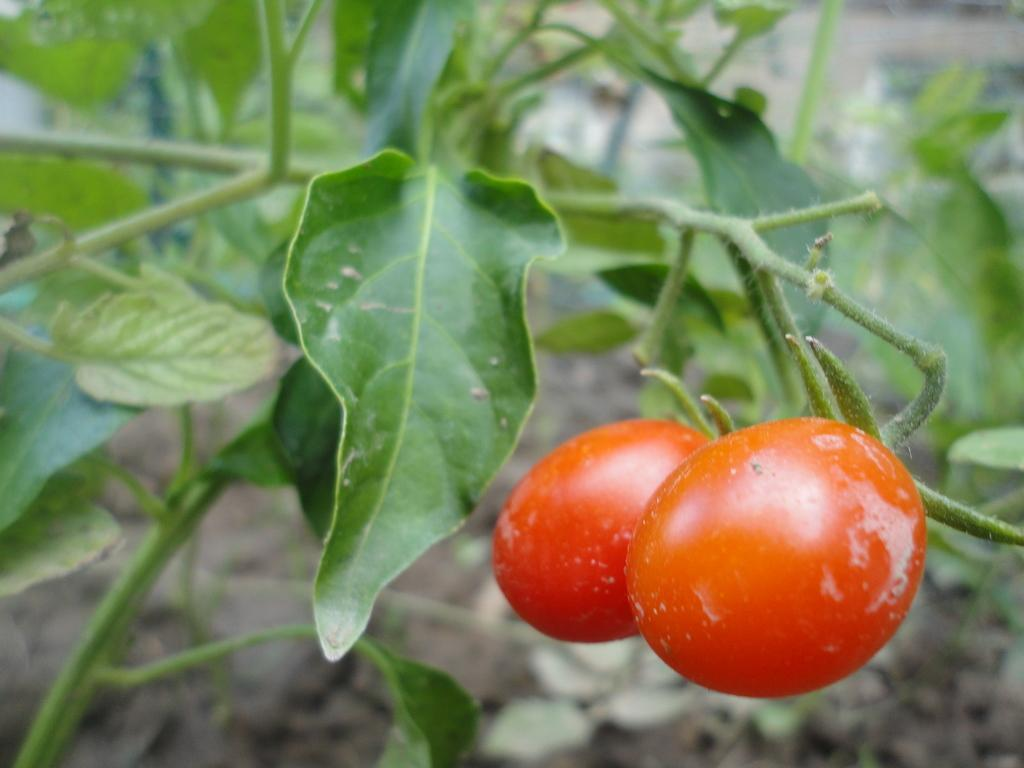What type of living organisms are present in the image? The image contains plants. What specific parts of the plants can be seen in the image? The plants have leaves and stems. Can you identify any specific fruits on the plants in the image? Yes, there are two red color tomatoes visible in the image. What type of birds can be seen perched on the faucet in the image? There is no faucet or birds present in the image; it features plants with leaves, stems, and tomatoes. Can you describe the goat grazing in the background of the image? There is no goat or grazing activity visible in the image; it only contains plants with leaves, stems, and tomatoes. 